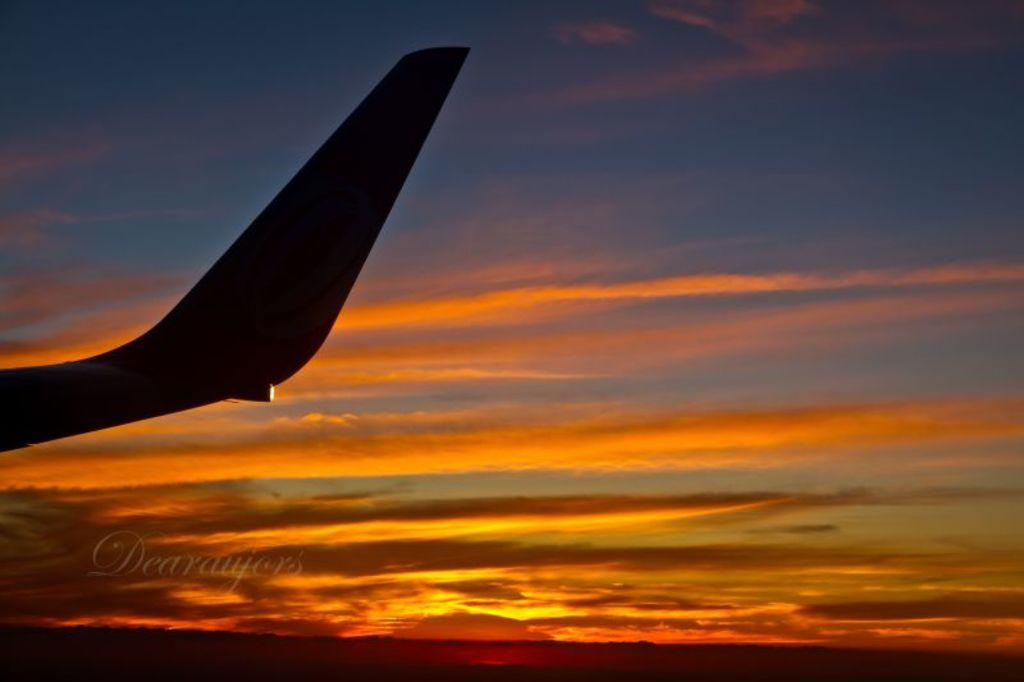Provide a one-sentence caption for the provided image. A plane tail with a sunset background with the water mark Dearaujes. 